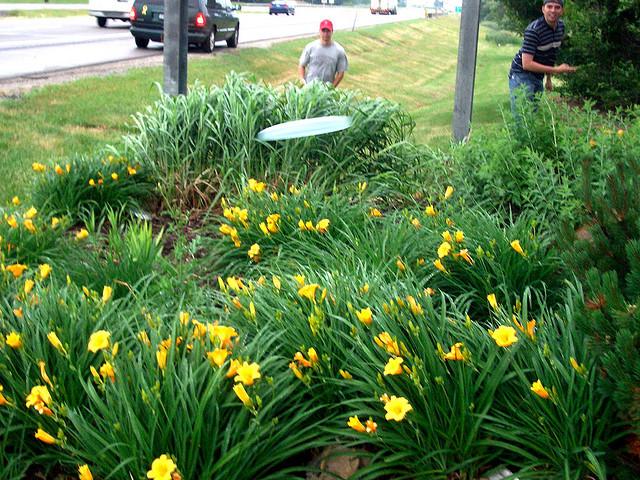Are these summer flowers?
Be succinct. Yes. Is the frisbee in clear focus?
Short answer required. No. Is it spring?
Give a very brief answer. Yes. Is this a potted floral arrangement?
Be succinct. No. What is in the vines?
Give a very brief answer. Flowers. How many purple flowers are there?
Answer briefly. 0. Is there an umbrella?
Concise answer only. No. Are these wild flowers?
Keep it brief. No. Which color are the flowers?
Give a very brief answer. Yellow. What kind of minivan is that?
Keep it brief. Black. 